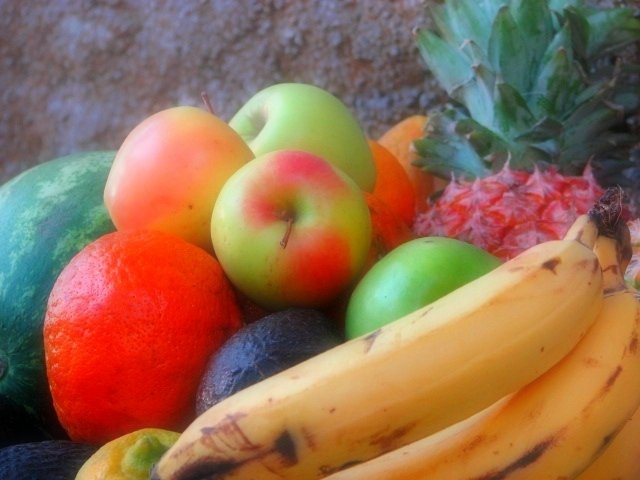Describe the objects in this image and their specific colors. I can see banana in gray, tan, and orange tones, orange in gray, red, maroon, and lightpink tones, apple in gray, olive, tan, and salmon tones, banana in gray, red, orange, and tan tones, and apple in gray, salmon, red, lightpink, and pink tones in this image. 